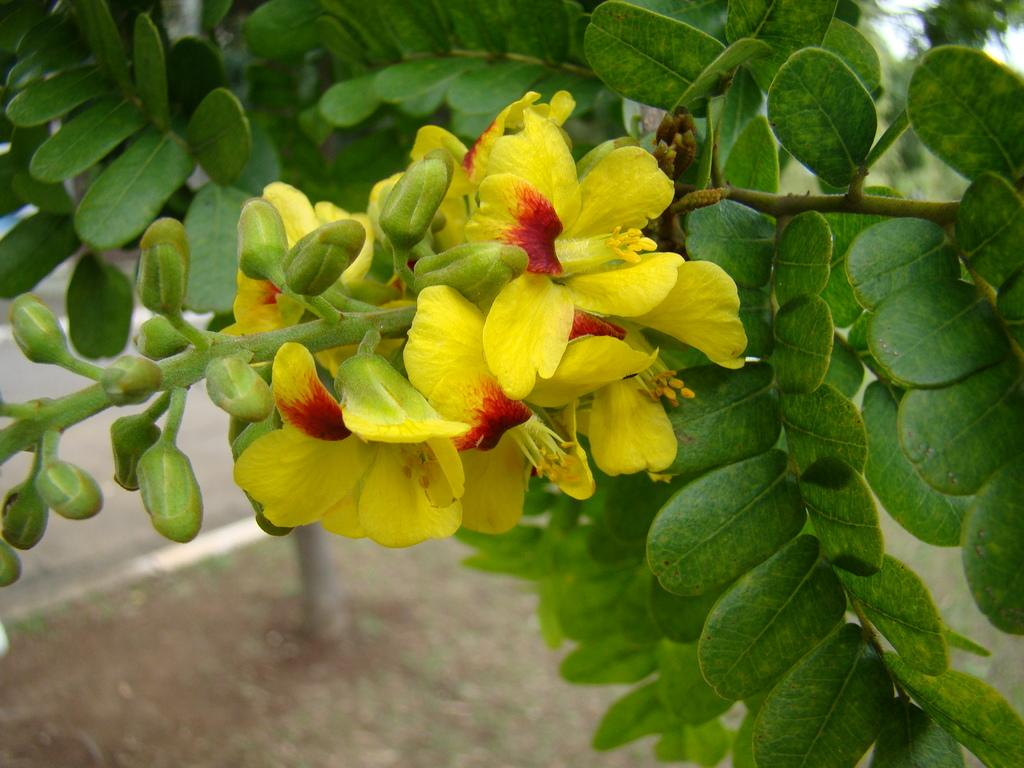What is the main subject in the center of the image? There are flowers in the center of the image. What else can be seen in the image besides flowers? Leaves and buds are visible in the image. What is the surface on which the flowers, leaves, and buds are resting? The ground is at the bottom of the image. How many representatives are present in the image? There are no representatives present in the image; it features flowers, leaves, and buds. What type of humor can be found in the image? There is no humor present in the image; it is a still image of flowers, leaves, and buds. 